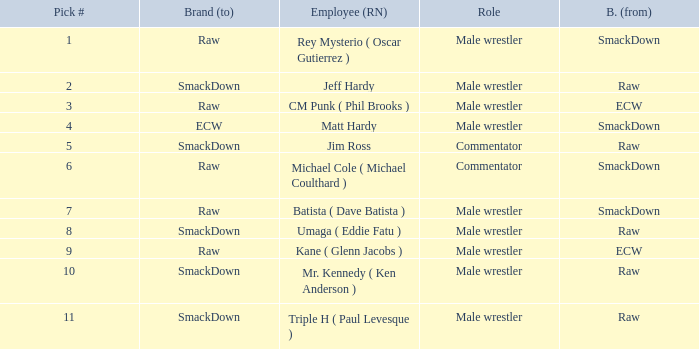What is the real name of the Pick # that is greater than 9? Mr. Kennedy ( Ken Anderson ), Triple H ( Paul Levesque ). 